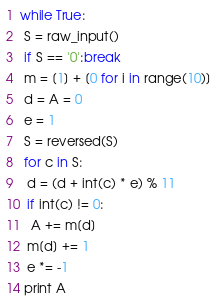<code> <loc_0><loc_0><loc_500><loc_500><_Python_>while True:
 S = raw_input()
 if S == '0':break
 m = [1] + [0 for i in range(10)]
 d = A = 0
 e = 1
 S = reversed(S)
 for c in S:
  d = (d + int(c) * e) % 11  
  if int(c) != 0:
   A += m[d]
  m[d] += 1
  e *= -1
 print A
</code> 